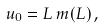<formula> <loc_0><loc_0><loc_500><loc_500>u _ { 0 } = L \, m ( L ) \, ,</formula> 